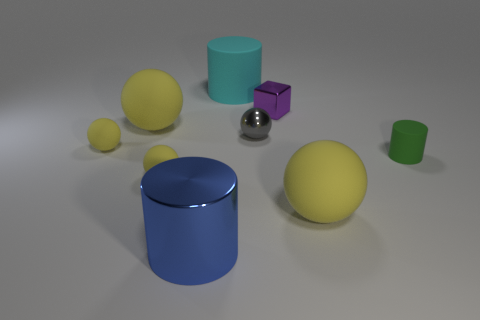Are there more yellow rubber objects that are on the left side of the small metal block than large yellow cylinders?
Your answer should be very brief. Yes. Are there any other things of the same color as the cube?
Provide a succinct answer. No. What shape is the small gray thing that is made of the same material as the small purple object?
Offer a very short reply. Sphere. Is the big yellow ball that is left of the purple cube made of the same material as the large blue cylinder?
Your answer should be compact. No. There is a big sphere that is to the right of the large shiny object; does it have the same color as the big matte ball on the left side of the blue object?
Give a very brief answer. Yes. What number of small objects are both to the right of the small gray metallic sphere and on the left side of the green matte cylinder?
Keep it short and to the point. 1. What is the material of the small green object?
Your response must be concise. Rubber. There is a green matte object that is the same size as the purple cube; what is its shape?
Provide a short and direct response. Cylinder. Do the small yellow ball that is behind the tiny green object and the tiny sphere right of the blue metal cylinder have the same material?
Provide a succinct answer. No. How many yellow spheres are there?
Offer a terse response. 4. 